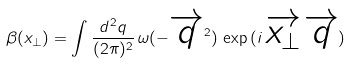<formula> <loc_0><loc_0><loc_500><loc_500>\beta ( x _ { \perp } ) = \int \frac { d ^ { 2 } q } { ( 2 \pi ) ^ { 2 } } \, \omega ( - \overrightarrow { q } ^ { 2 } ) \, \exp \, ( i \, \overrightarrow { x _ { \perp } } \, \overrightarrow { q } )</formula> 